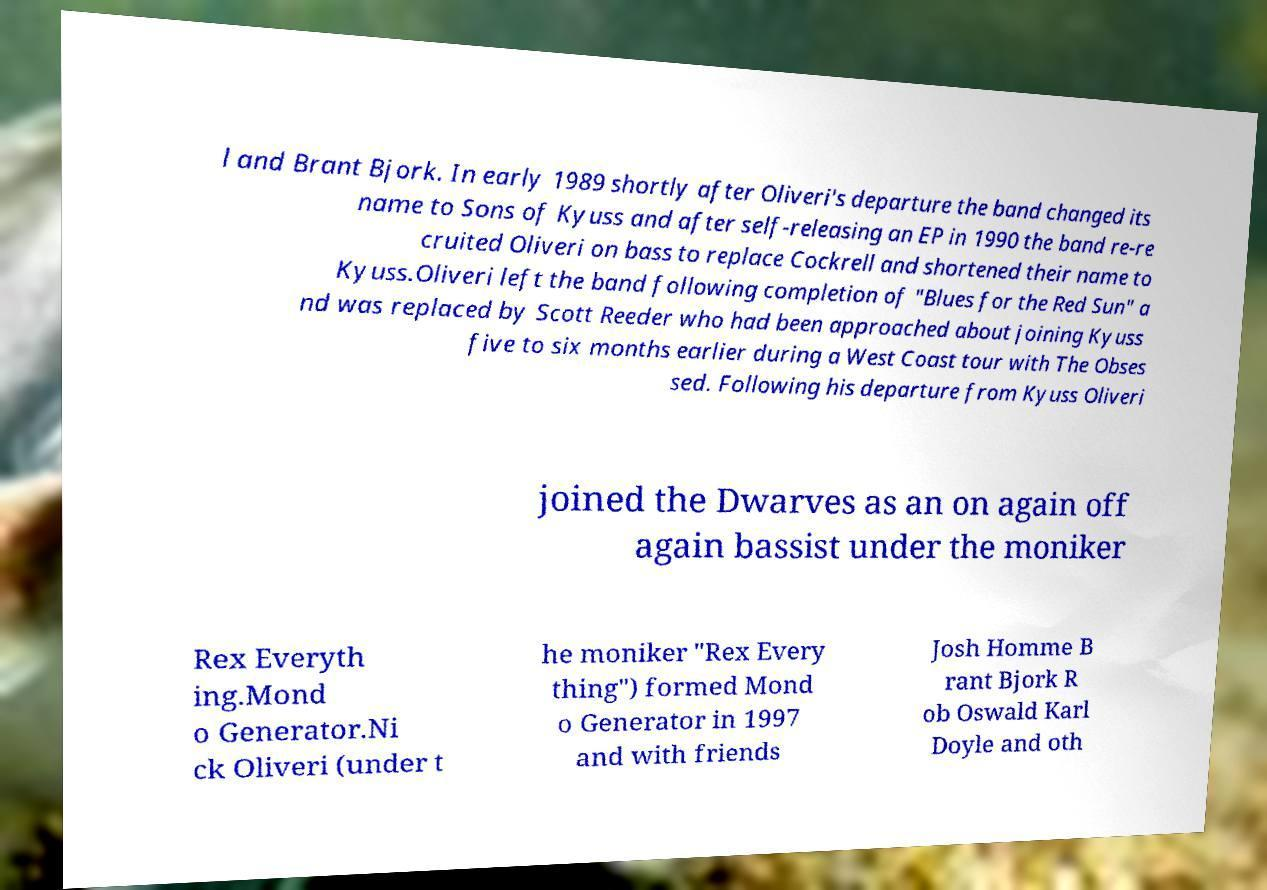Could you assist in decoding the text presented in this image and type it out clearly? l and Brant Bjork. In early 1989 shortly after Oliveri's departure the band changed its name to Sons of Kyuss and after self-releasing an EP in 1990 the band re-re cruited Oliveri on bass to replace Cockrell and shortened their name to Kyuss.Oliveri left the band following completion of "Blues for the Red Sun" a nd was replaced by Scott Reeder who had been approached about joining Kyuss five to six months earlier during a West Coast tour with The Obses sed. Following his departure from Kyuss Oliveri joined the Dwarves as an on again off again bassist under the moniker Rex Everyth ing.Mond o Generator.Ni ck Oliveri (under t he moniker "Rex Every thing") formed Mond o Generator in 1997 and with friends Josh Homme B rant Bjork R ob Oswald Karl Doyle and oth 